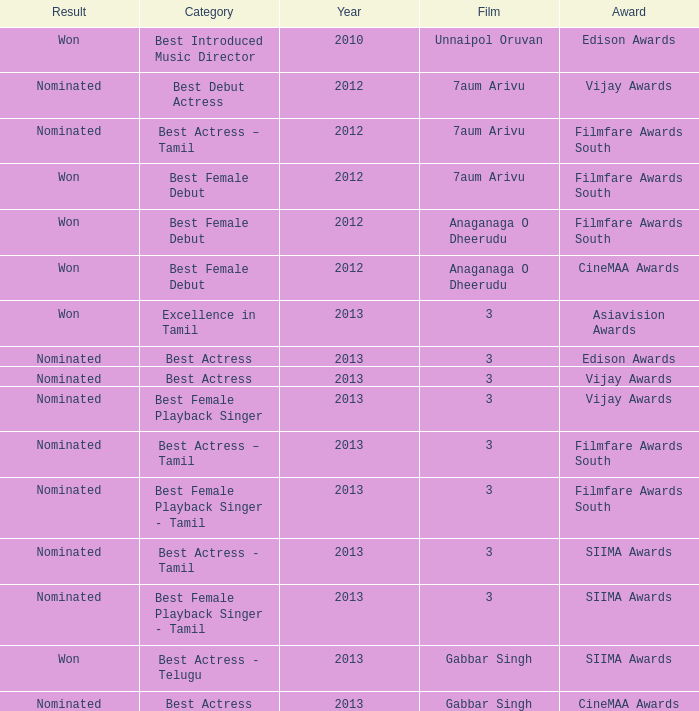What was the result associated with the cinemaa awards, and gabbar singh film? Nominated. 